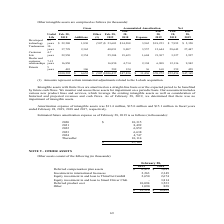According to Calamp's financial document, What did ThinxNet do in August 2018? Based on the financial document, the answer is commenced a subsequent financing transaction to raise additional funds for working capital purposes.. Also, How much was deferred compensation in 2019? According to the financial document, 6,413 (in thousands). The relevant text states: "28, 2019 2018 Deferred compensation plan assets $ 6,413 $ 5,641 Investment in international licensees 2,263 2,349 Equity investment in and loan to ThinxNet..." Also, How much was deferred product cost in 2019? According to the financial document, 10,094 (in thousands). The relevant text states: "o Smart Driver Club - 3,814 Deferred product cost 10,094 3,523 Other 1,090 828 $ 22,510 $ 18,829..." Also, can you calculate: What was the change in investment in international licenses from 2018 to 2019? Based on the calculation: (2,349-2,263), the result is 86 (in thousands). This is based on the information: "413 $ 5,641 Investment in international licensees 2,263 2,349 Equity investment in and loan to ThinxNet GmbH 2,650 2,674 Equity investment in and loan to S 5,641 Investment in international licensees ..." The key data points involved are: 2,263, 2,349. Also, can you calculate: What was the percentage change in product costs from 2018 to 2019? To answer this question, I need to perform calculations using the financial data. The calculation is: (10,094-3,523)/3,523, which equals 186.52 (percentage). This is based on the information: "o Smart Driver Club - 3,814 Deferred product cost 10,094 3,523 Other 1,090 828 $ 22,510 $ 18,829 Driver Club - 3,814 Deferred product cost 10,094 3,523 Other 1,090 828 $ 22,510 $ 18,829..." The key data points involved are: 10,094, 3,523. Also, can you calculate: How much do the top 3 assets add up to in 2018? Based on the calculation: (5,641+3,814+3,523), the result is 12978 (in thousands). This is based on the information: "ity investment in and loan to Smart Driver Club - 3,814 Deferred product cost 10,094 3,523 Other 1,090 828 $ 22,510 $ 18,829 2018 Deferred compensation plan assets $ 6,413 $ 5,641 Investment in intern..." The key data points involved are: 3,523, 3,814, 5,641. 